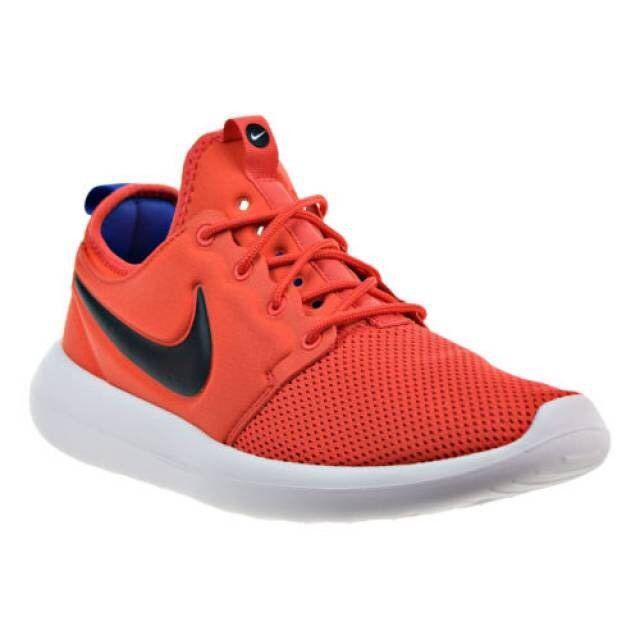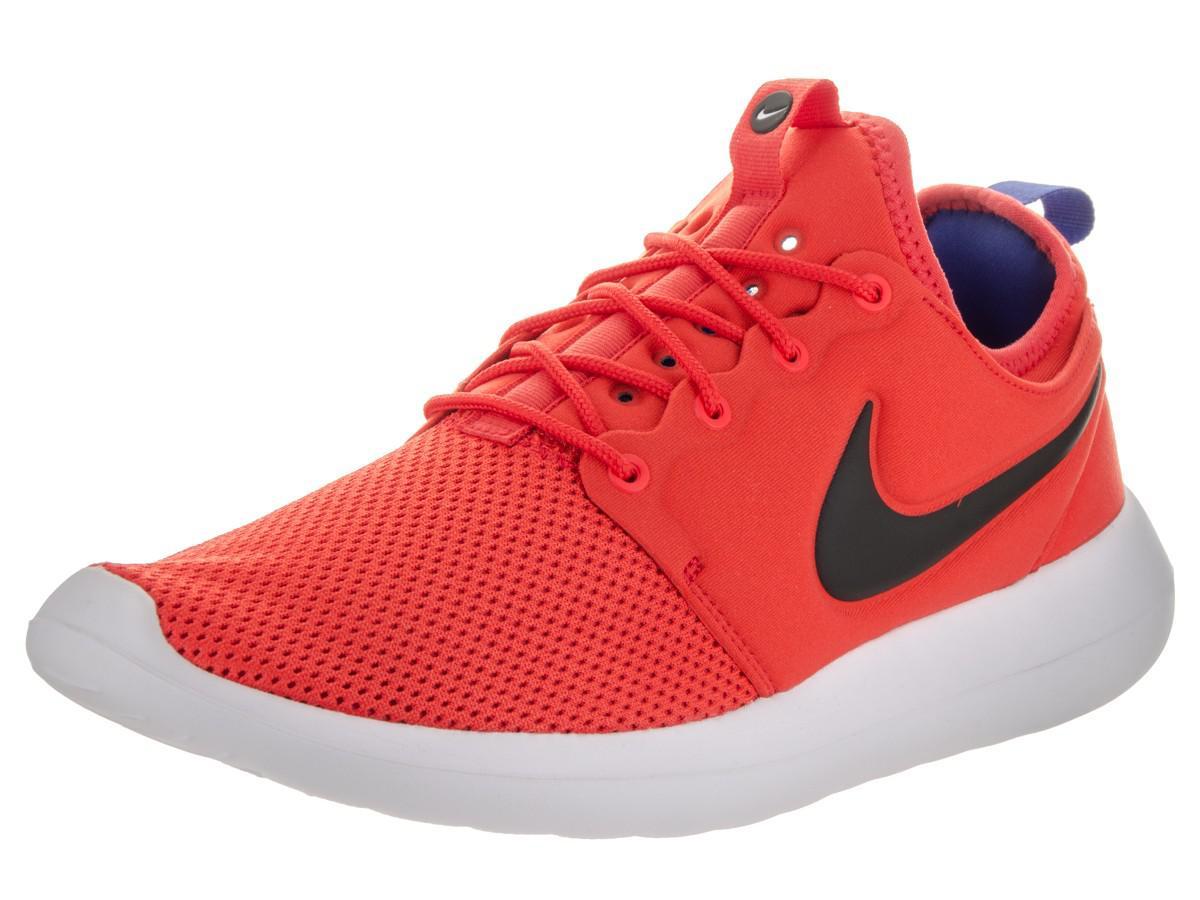The first image is the image on the left, the second image is the image on the right. For the images shown, is this caption "The pair of shoes is on the left of the single shoe." true? Answer yes or no. No. The first image is the image on the left, the second image is the image on the right. Assess this claim about the two images: "Left image shows a pair of orange sneakers, and right image shows just one sneaker.". Correct or not? Answer yes or no. No. 